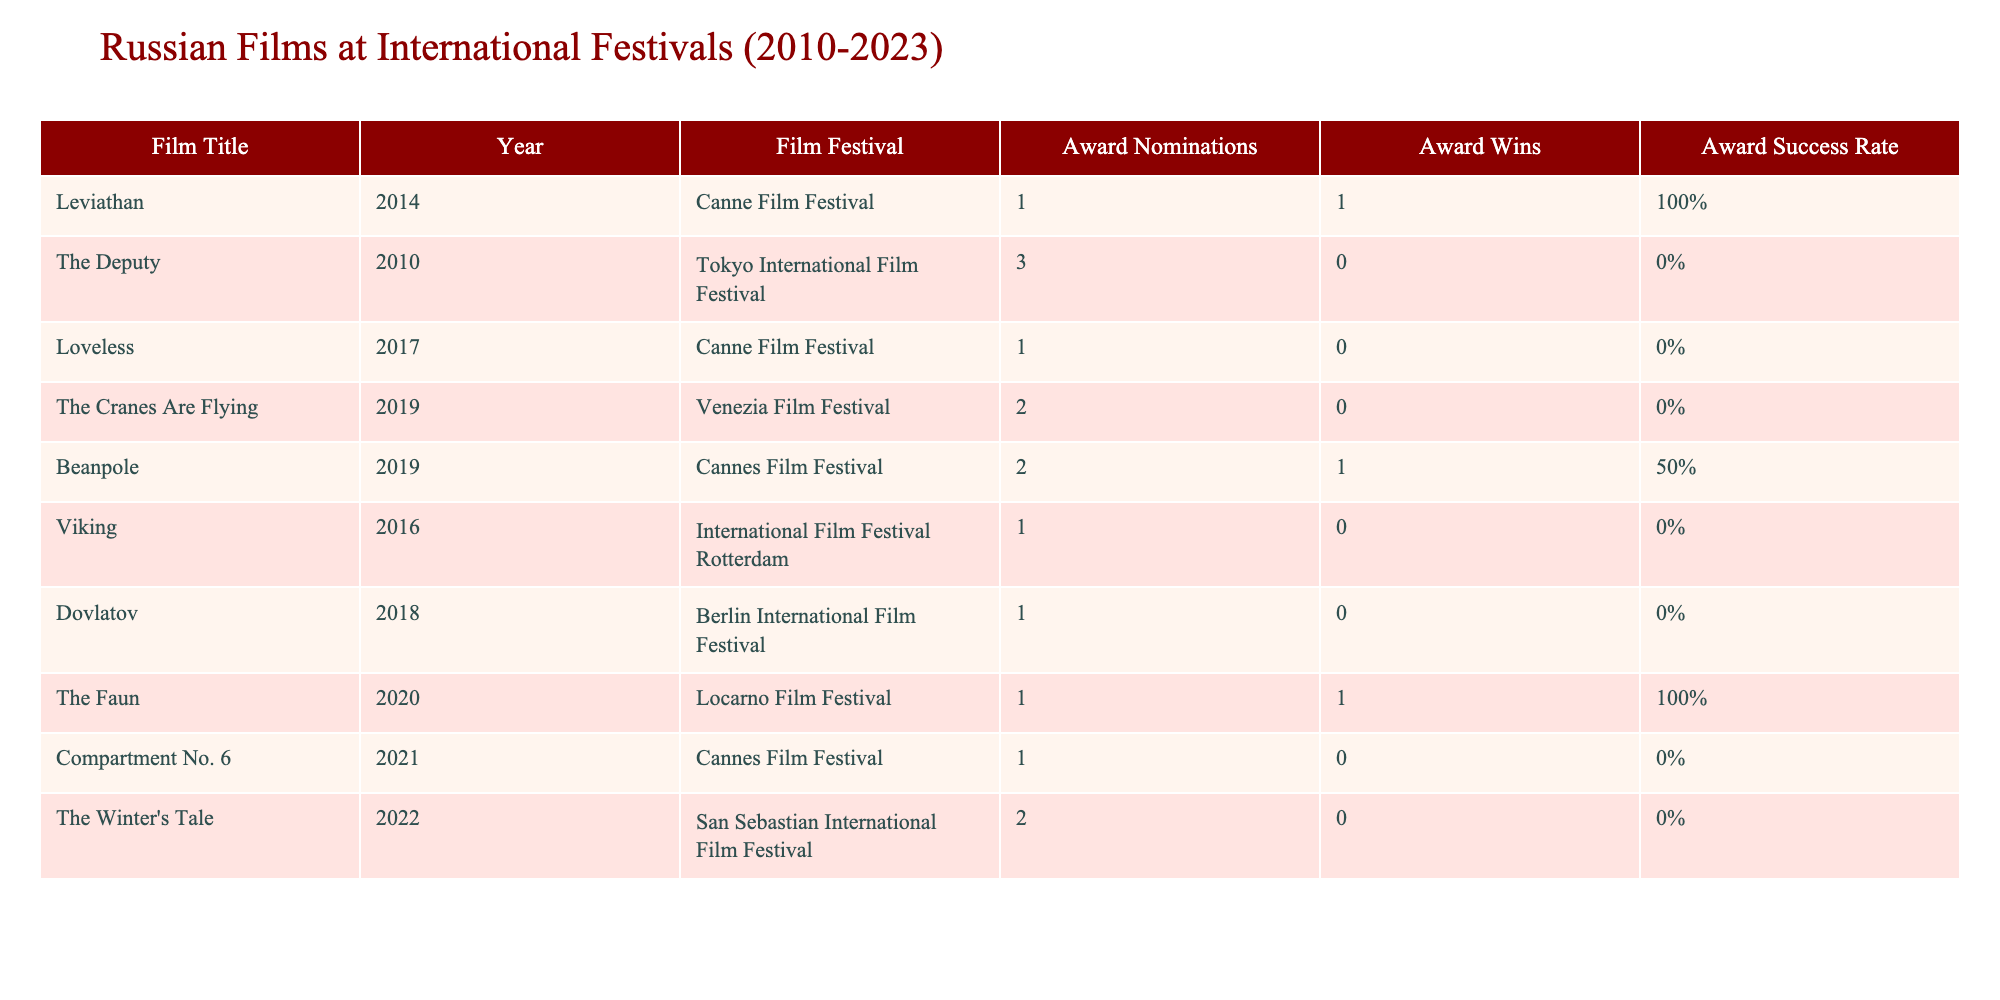What Russian film won the most awards at an international film festival? The only film listed with more than one award win is "Leviathan," which won 1 award from 1 nomination. No other films show multiple wins; hence, it is the only one recognized.
Answer: Leviathan How many films received no wins despite having nominations? By examining the table, the films "The Deputy," "Loveless," "The Cranes Are Flying," "Viking," "Dovlatov," "Compartment No. 6," and "The Winter's Tale" all have nominations but no wins. Counting these gives us a total of 6 films.
Answer: 6 What is the average number of award wins for all Russian films listed? The total number of award wins from all the films is (1 + 0 + 0 + 0 + 1 + 0 + 0 + 1 + 0 + 0 = 3). There are 10 films in total, so the average win is 3/10 = 0.3.
Answer: 0.3 Is it true that all films listed had nominations at the Cannes Film Festival? The table shows that some films like "The Faun" and "The Winter's Tale" did not premiere at the Cannes Film Festival, thus it is not true that all listed films had nominations there.
Answer: No Which film had the highest success rate of award wins to nominations? To find the highest success rate, calculate the success rate (wins/nominations) for each film. "Leviathan" is 1/1 = 1, "Beanpole" is 1/2 = 0.5, and for "The Faun," it is 1/1 = 1. All have a success rate of 100%, but since they both have the same rate, they are tied for the highest.
Answer: Leviathan and The Faun How many total nominations did Russian films receive from the listed festivals? To find this, sum the nominations: 1+3+1+2+2+1+1+1+2 = 14, so the total number of nominations is 14.
Answer: 14 What is the success rate of the film "Compartment No. 6"? "Compartment No. 6" has 0 wins and 1 nomination. Calculating the success rate gives 0/1 = 0. The success rate is therefore 0%.
Answer: 0% 